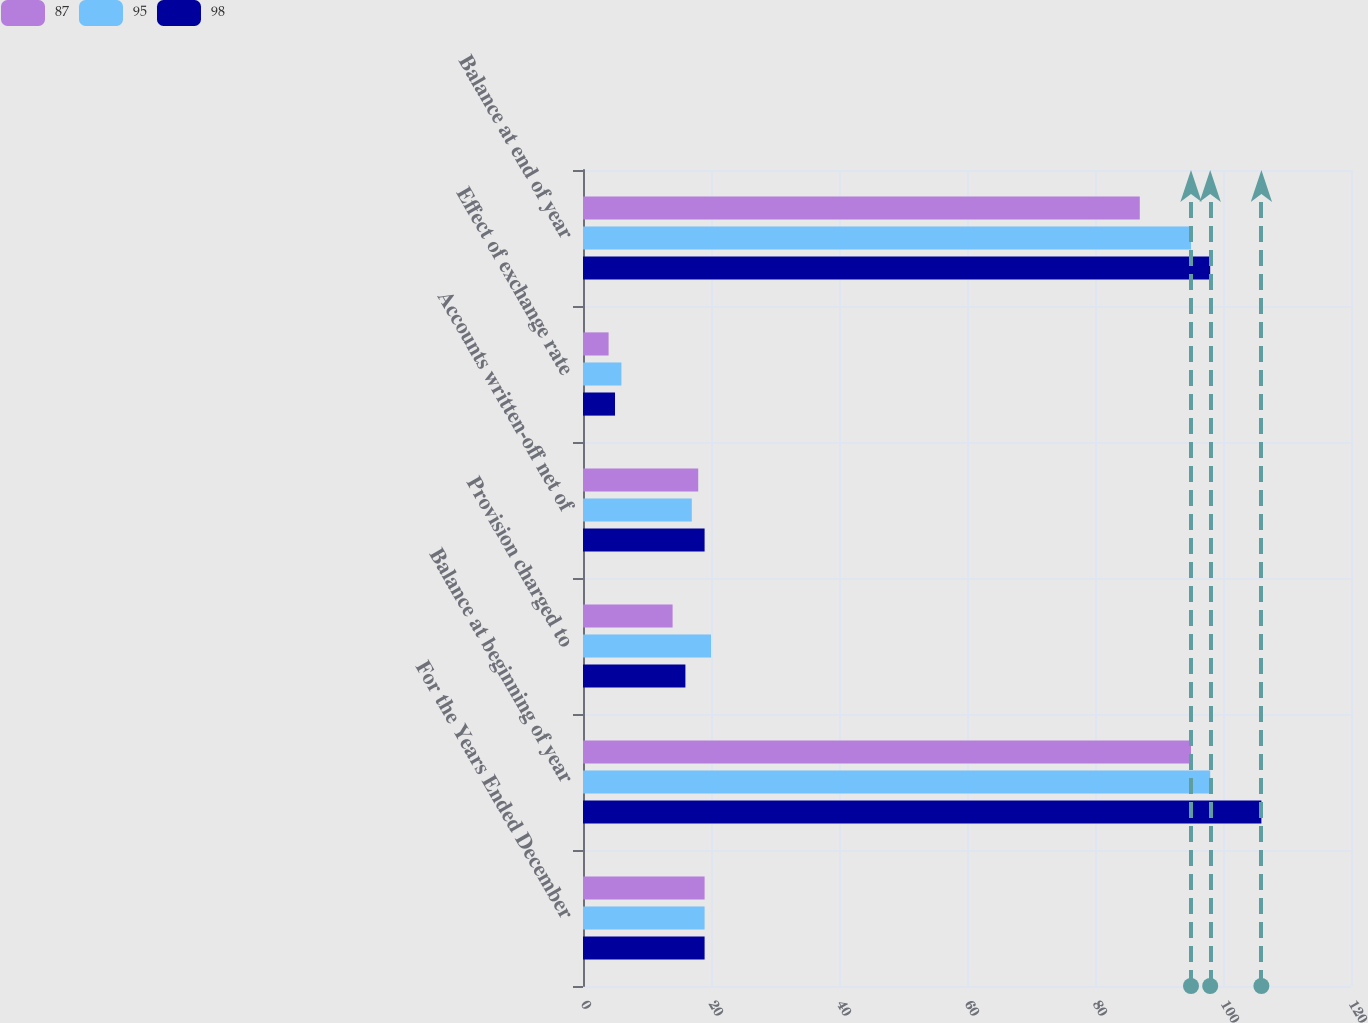<chart> <loc_0><loc_0><loc_500><loc_500><stacked_bar_chart><ecel><fcel>For the Years Ended December<fcel>Balance at beginning of year<fcel>Provision charged to<fcel>Accounts written-off net of<fcel>Effect of exchange rate<fcel>Balance at end of year<nl><fcel>87<fcel>19<fcel>95<fcel>14<fcel>18<fcel>4<fcel>87<nl><fcel>95<fcel>19<fcel>98<fcel>20<fcel>17<fcel>6<fcel>95<nl><fcel>98<fcel>19<fcel>106<fcel>16<fcel>19<fcel>5<fcel>98<nl></chart> 